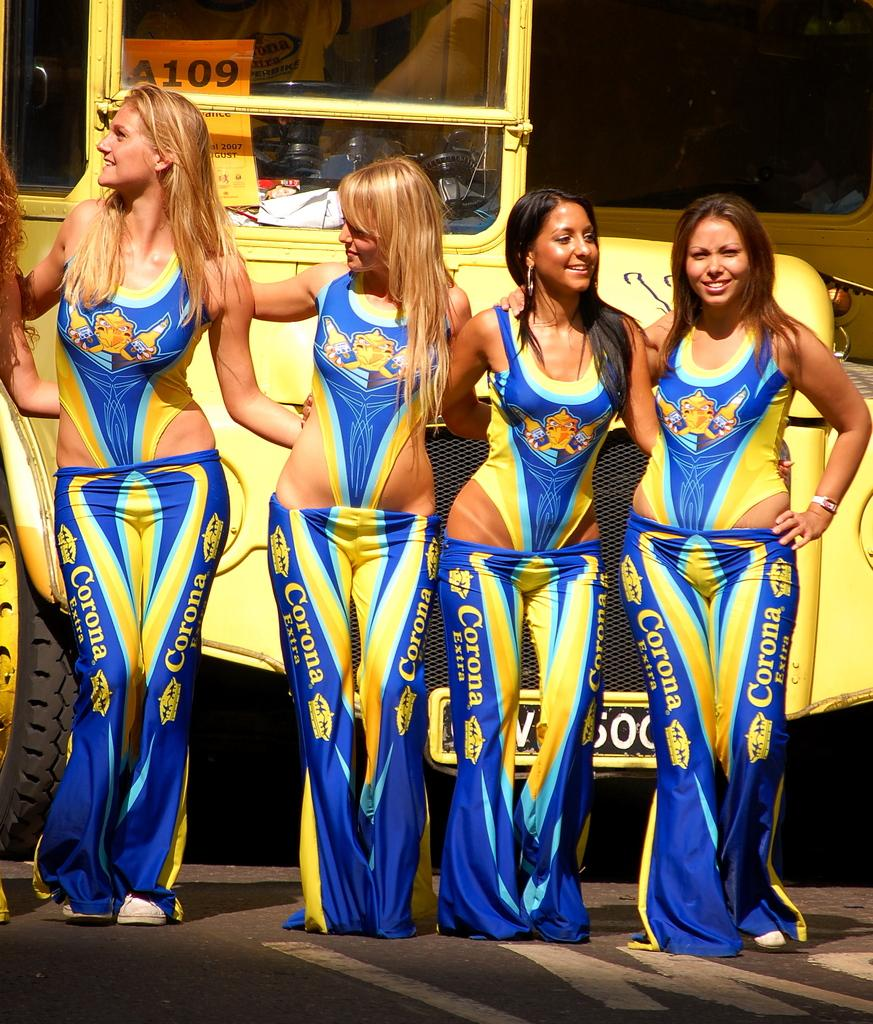<image>
Describe the image concisely. Four girls in clothes that say Corona are standing in front of a yellow bus. 